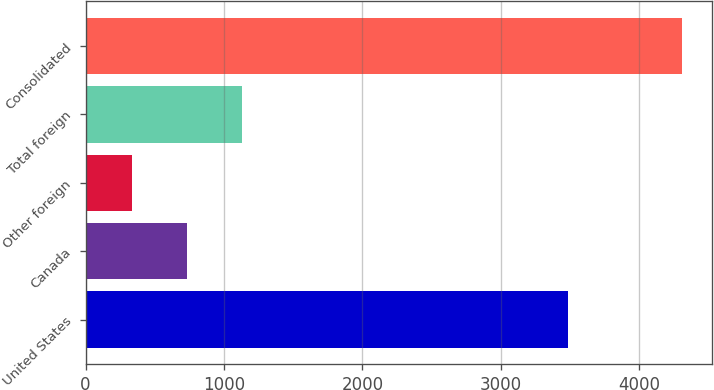Convert chart to OTSL. <chart><loc_0><loc_0><loc_500><loc_500><bar_chart><fcel>United States<fcel>Canada<fcel>Other foreign<fcel>Total foreign<fcel>Consolidated<nl><fcel>3484.9<fcel>730.89<fcel>333.4<fcel>1128.38<fcel>4308.3<nl></chart> 